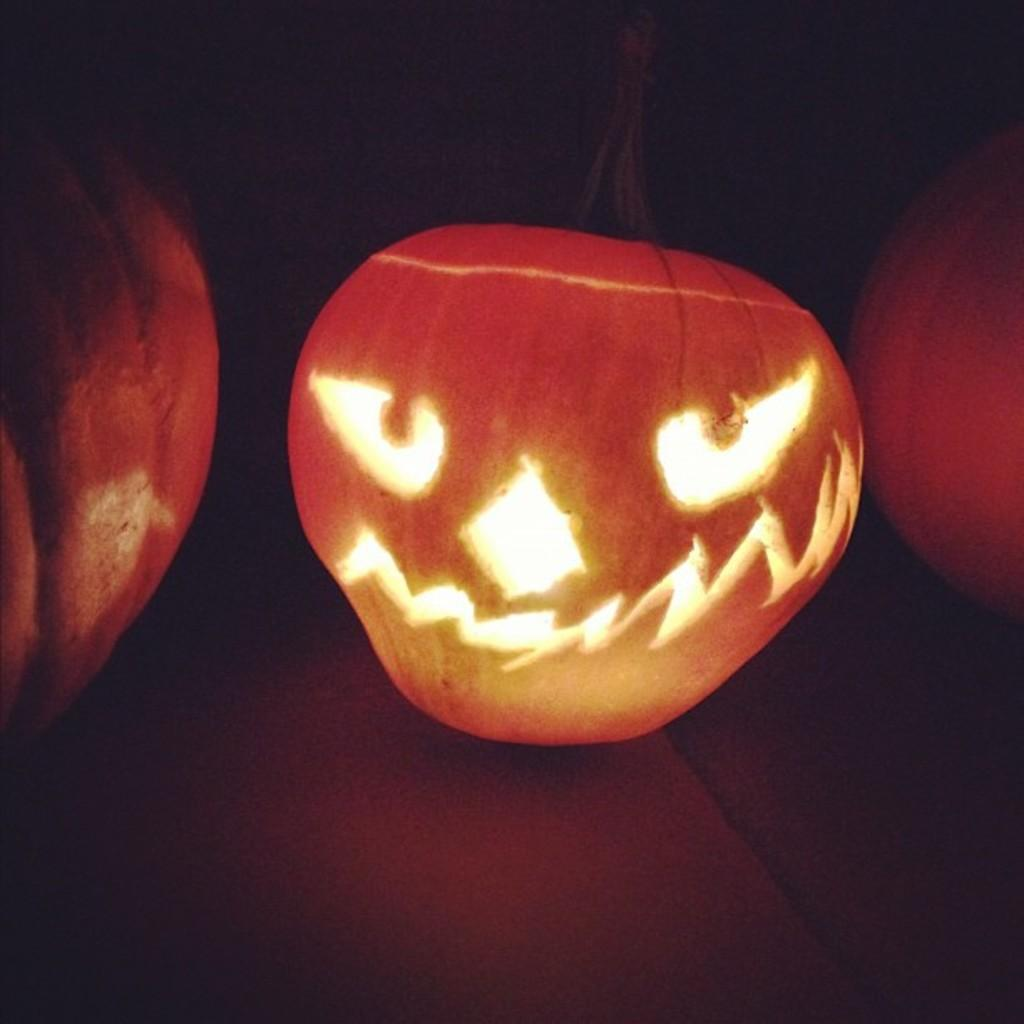What is the main subject of the image? The main subject of the image is a group of pumpkins. Where are the pumpkins located in the image? The pumpkins are placed on the floor. Can you describe any specific details about the pumpkins? One pumpkin is carved in the shape of a face. What type of drink is being served by the servant in the image? There is no servant or drink present in the image; it features a group of pumpkins on the floor. 